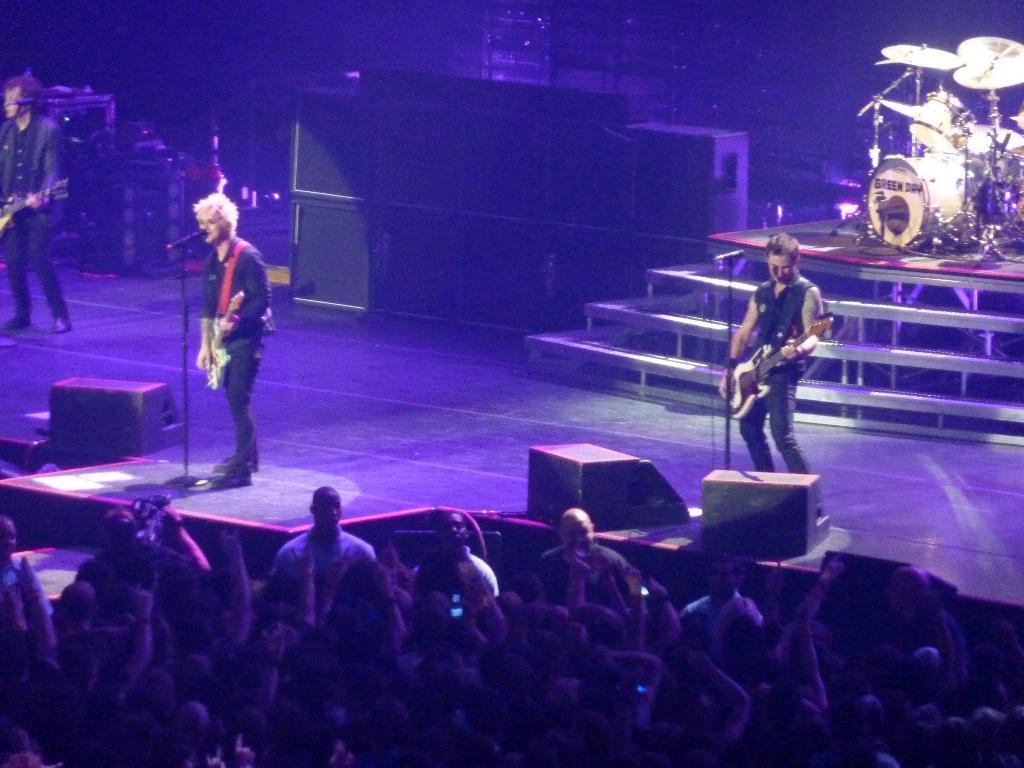Can you describe this image briefly? In this image there are three people who are playing the guitar on the stage. At the background there is a drums and musical plates. In front of them there is a crowd. 